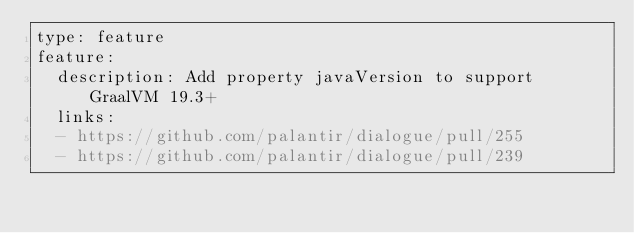<code> <loc_0><loc_0><loc_500><loc_500><_YAML_>type: feature
feature:
  description: Add property javaVersion to support GraalVM 19.3+
  links:
  - https://github.com/palantir/dialogue/pull/255
  - https://github.com/palantir/dialogue/pull/239
</code> 